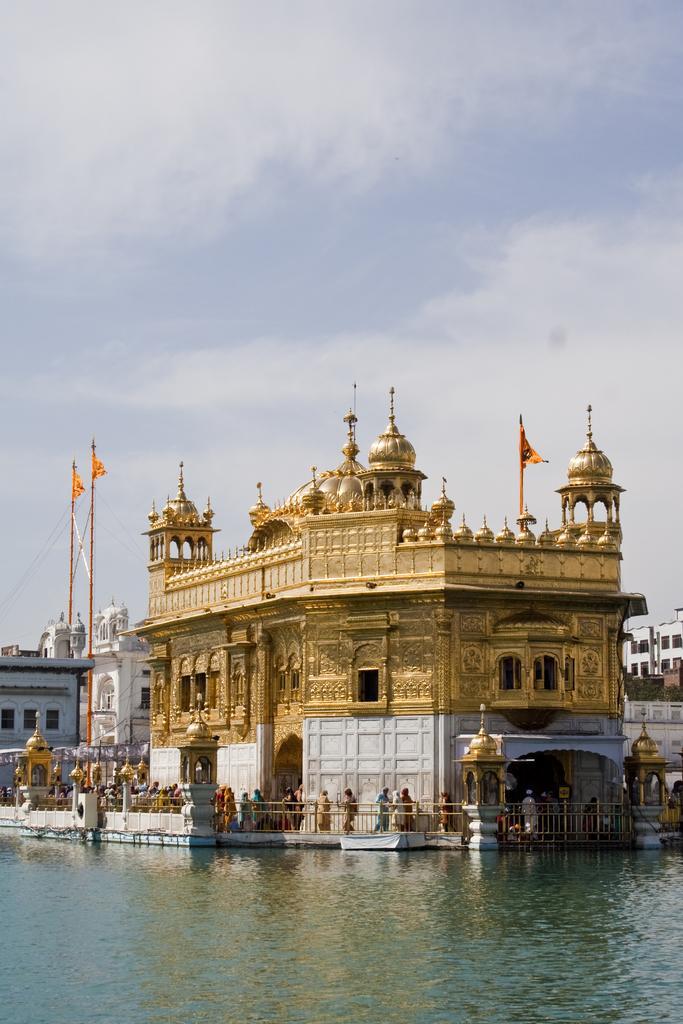Could you give a brief overview of what you see in this image? In this image I can see water in the front. In the background I can see the Golden Temple, few poles, few flags, few buildings, number of people, cloud and the sky. 